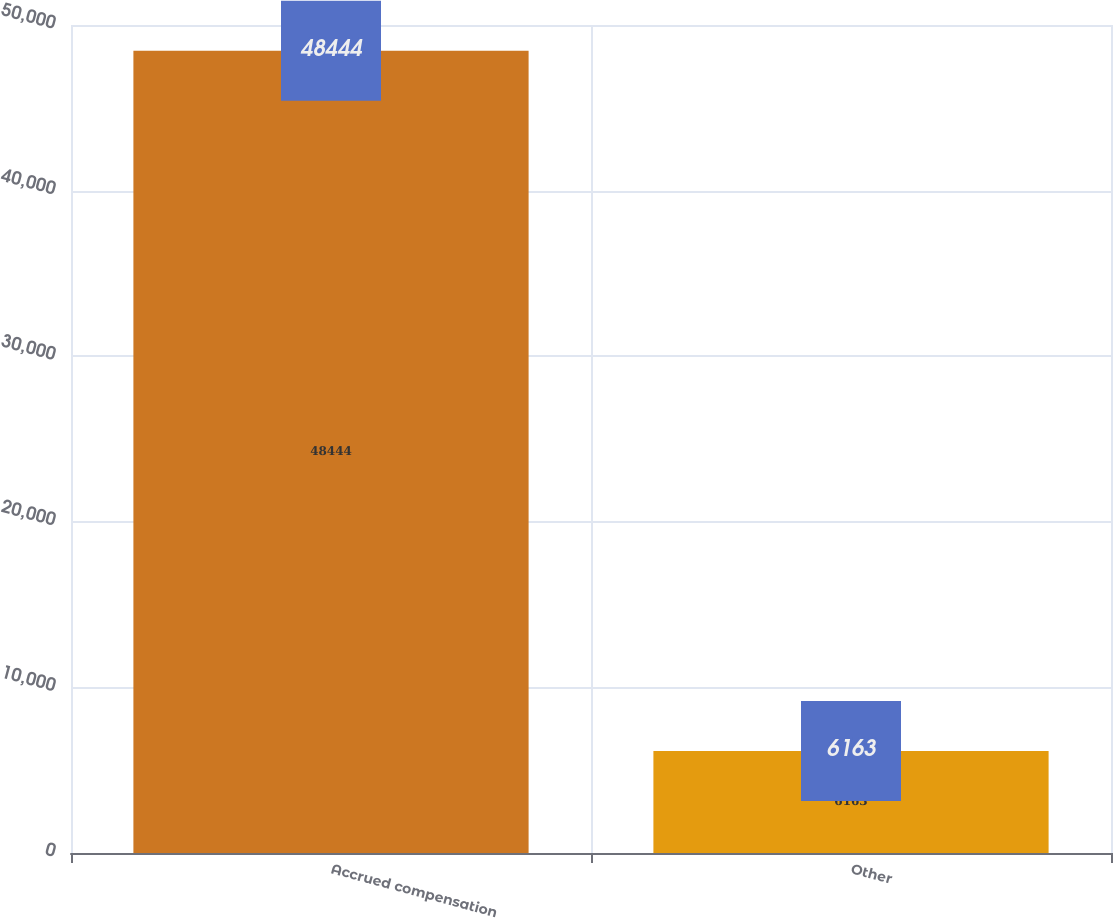<chart> <loc_0><loc_0><loc_500><loc_500><bar_chart><fcel>Accrued compensation<fcel>Other<nl><fcel>48444<fcel>6163<nl></chart> 